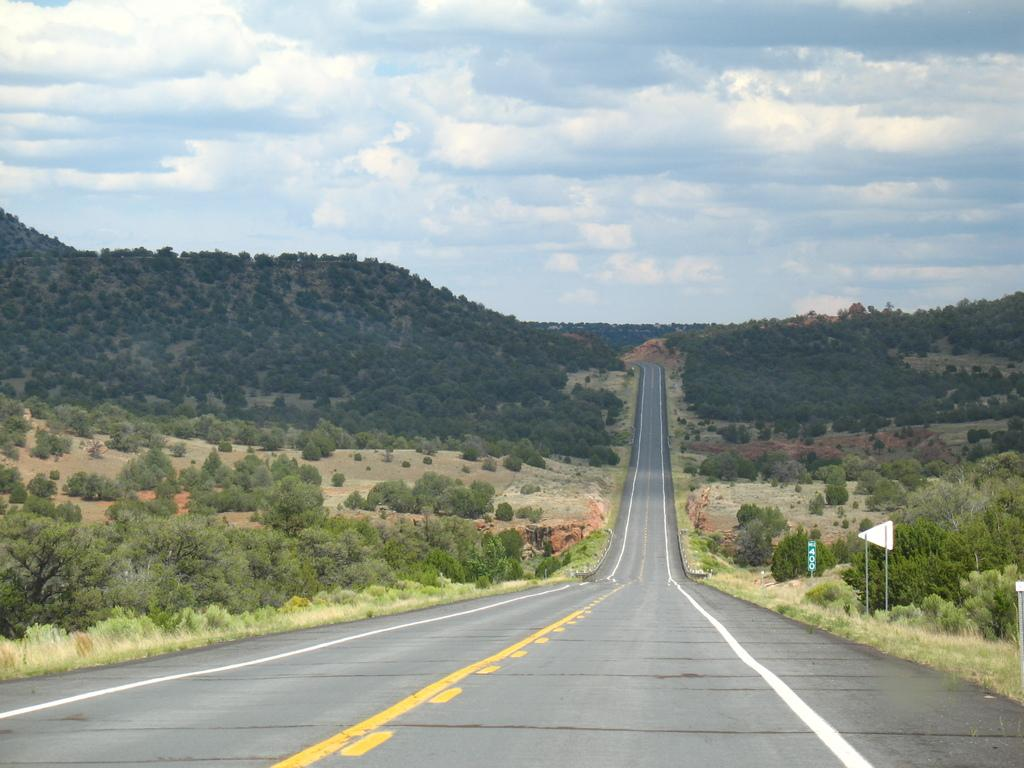What is the main feature in the center of the image? There is a road in the center of the image. What can be seen on the left side of the image? There are trees on the left side of the image. What can be seen on the right side of the image? There are trees on the right side of the image. What objects are present in the image besides the road and trees? There are boards and poles in the image. How would you describe the sky in the image? The sky is cloudy in the image. What type of quilt is draped over the trees in the image? There is no quilt present in the image; it features a road, trees, boards, and poles. How many birds can be seen flying in the image? There are no birds visible in the image. 